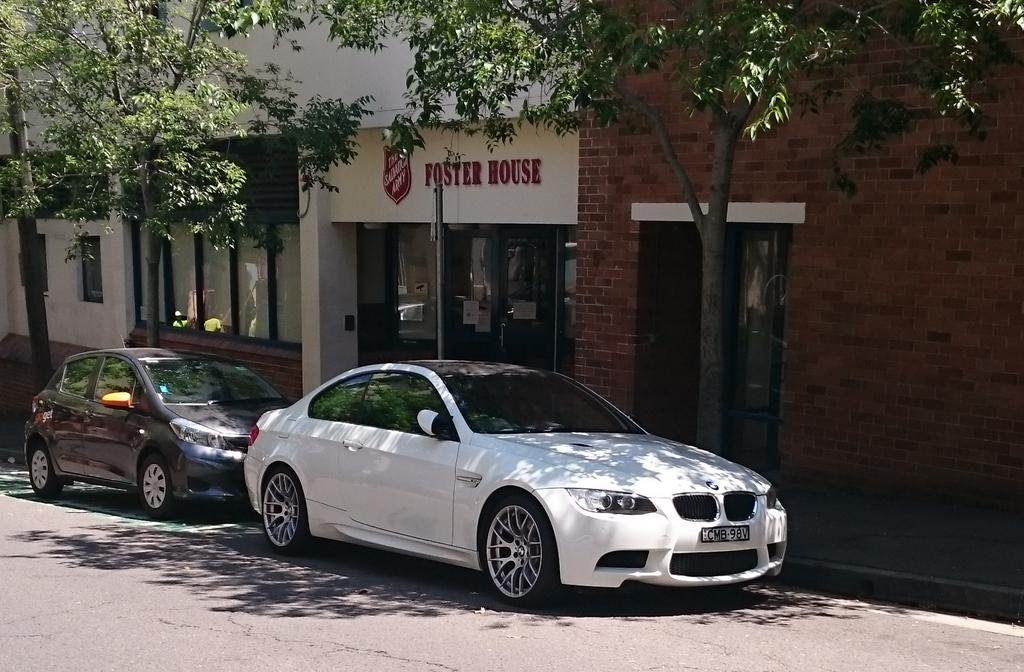What is the main subject of the image? The main subject of the image is cars on a road. What can be seen in the background of the image? In the background of the image, there are trees and shops visible. What type of plate is being used to cause the earthquake in the image? There is no plate or earthquake present in the image. 